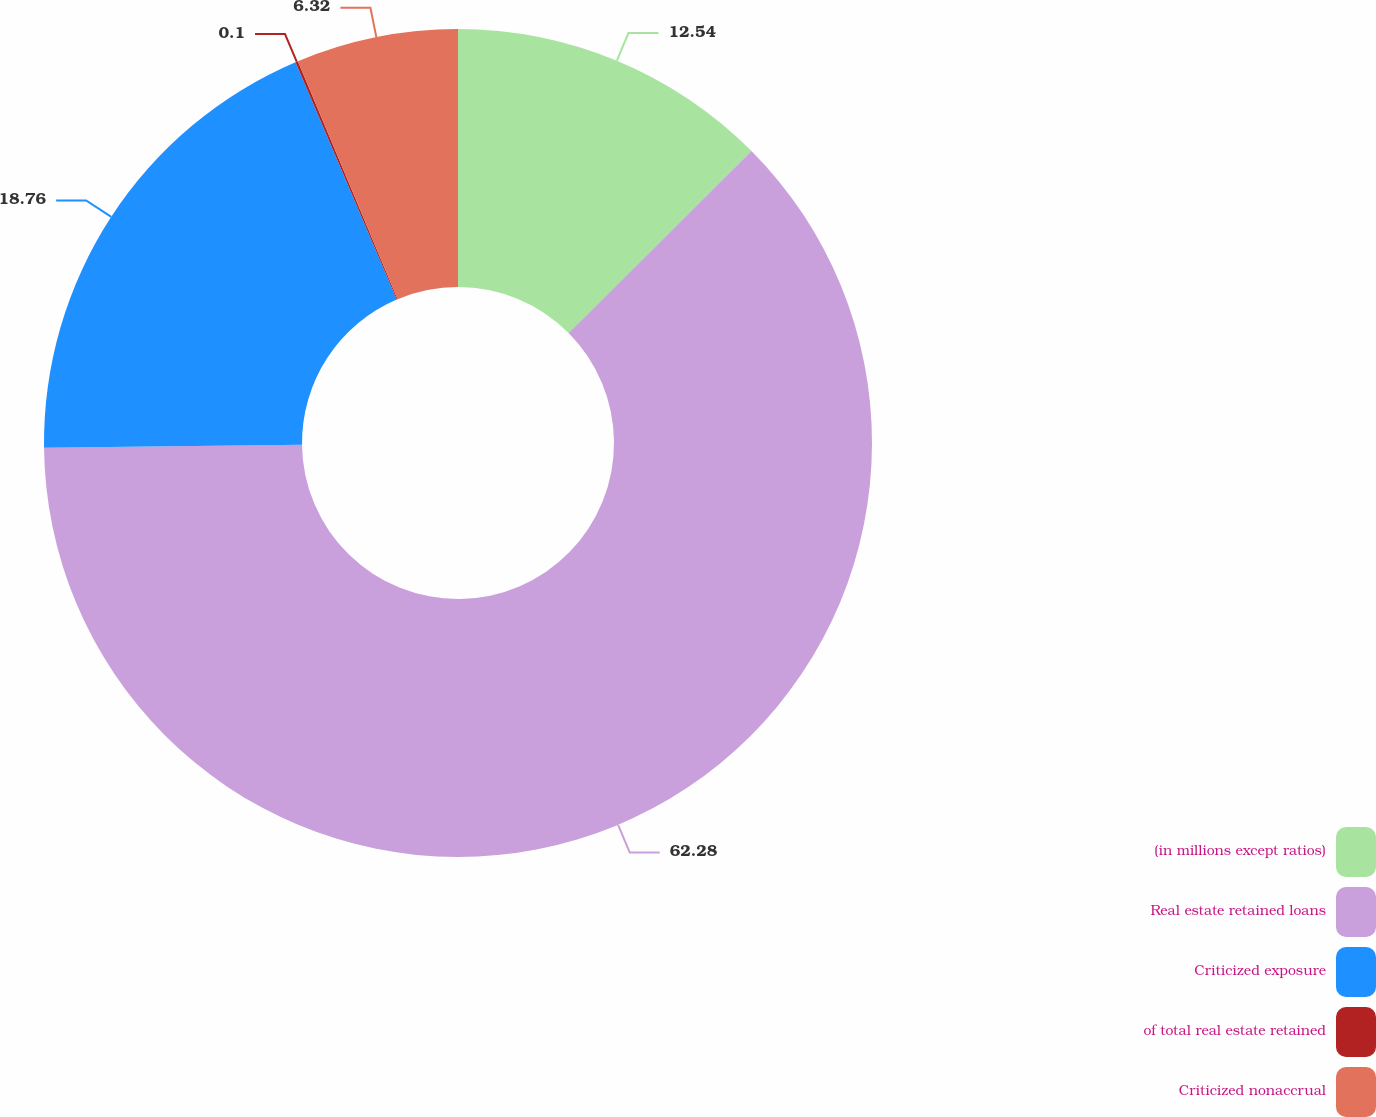Convert chart to OTSL. <chart><loc_0><loc_0><loc_500><loc_500><pie_chart><fcel>(in millions except ratios)<fcel>Real estate retained loans<fcel>Criticized exposure<fcel>of total real estate retained<fcel>Criticized nonaccrual<nl><fcel>12.54%<fcel>62.28%<fcel>18.76%<fcel>0.1%<fcel>6.32%<nl></chart> 